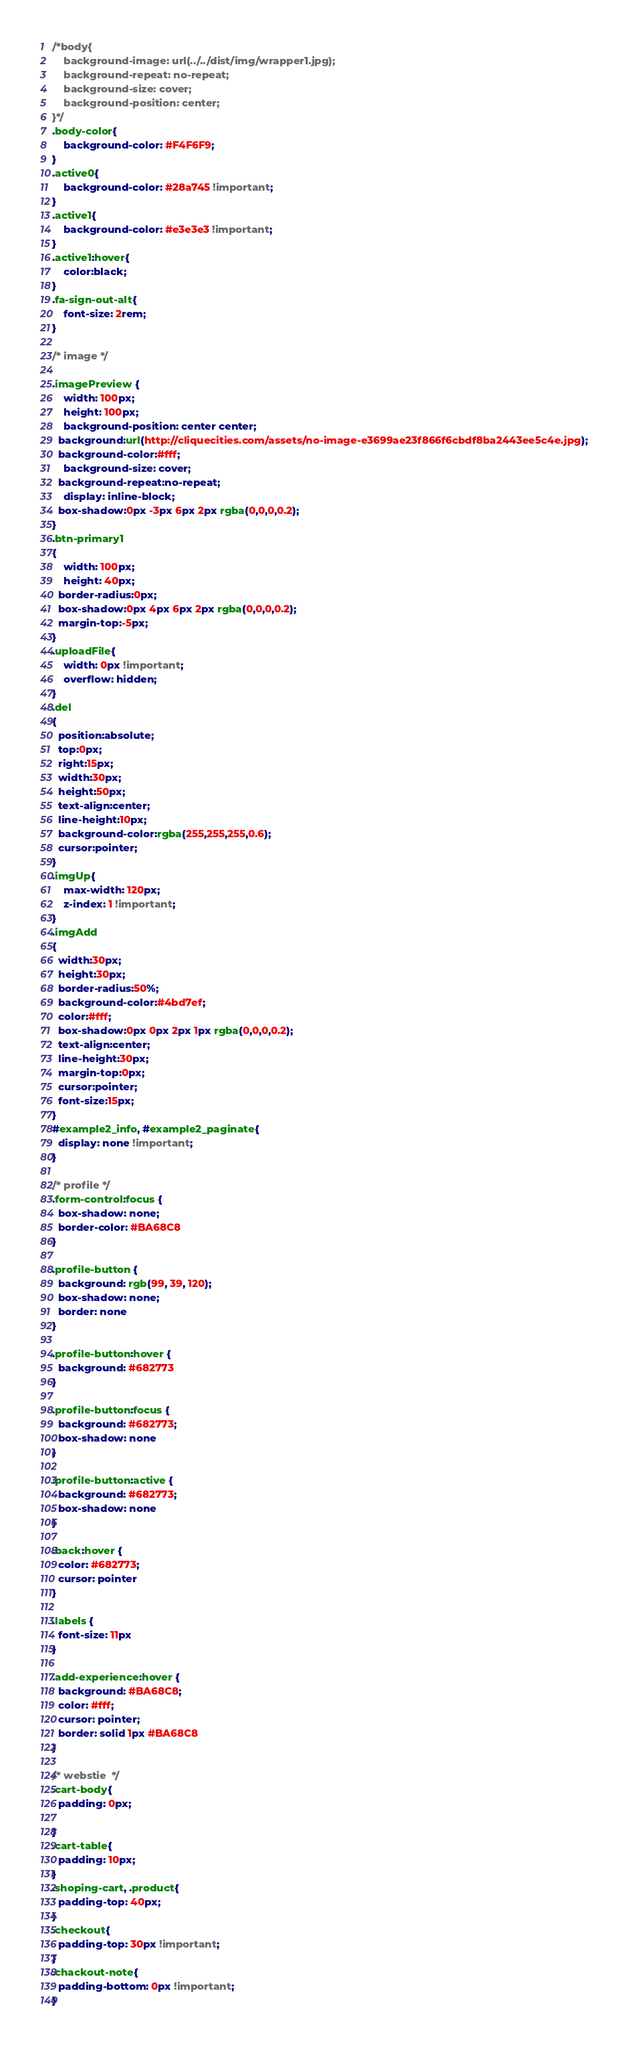<code> <loc_0><loc_0><loc_500><loc_500><_CSS_>/*body{
    background-image: url(../../dist/img/wrapper1.jpg);
    background-repeat: no-repeat;
    background-size: cover;
    background-position: center;
}*/
.body-color{
    background-color: #F4F6F9;
}
.active0{
    background-color: #28a745 !important;
}
.active1{
    background-color: #e3e3e3 !important;
}
.active1:hover{
    color:black;
}
.fa-sign-out-alt{
    font-size: 2rem;
}

/* image */

.imagePreview {
    width: 100px;
    height: 100px;
    background-position: center center;
  background:url(http://cliquecities.com/assets/no-image-e3699ae23f866f6cbdf8ba2443ee5c4e.jpg);
  background-color:#fff;
    background-size: cover;
  background-repeat:no-repeat;
    display: inline-block;
  box-shadow:0px -3px 6px 2px rgba(0,0,0,0.2);
}
.btn-primary1
{
    width: 100px;
    height: 40px;
  border-radius:0px;
  box-shadow:0px 4px 6px 2px rgba(0,0,0,0.2);
  margin-top:-5px;
}
.uploadFile{
    width: 0px !important;
    overflow: hidden;
}
.del
{
  position:absolute;
  top:0px;
  right:15px;
  width:30px;
  height:50px;
  text-align:center;
  line-height:10px;
  background-color:rgba(255,255,255,0.6);
  cursor:pointer;
}
.imgUp{
    max-width: 120px;
    z-index: 1 !important;
}
.imgAdd
{
  width:30px;
  height:30px;
  border-radius:50%;
  background-color:#4bd7ef;
  color:#fff;
  box-shadow:0px 0px 2px 1px rgba(0,0,0,0.2);
  text-align:center;
  line-height:30px;
  margin-top:0px;
  cursor:pointer;
  font-size:15px;
}
#example2_info, #example2_paginate{
  display: none !important;
}

/* profile */
.form-control:focus {
  box-shadow: none;
  border-color: #BA68C8
}

.profile-button {
  background: rgb(99, 39, 120);
  box-shadow: none;
  border: none
}

.profile-button:hover {
  background: #682773
}

.profile-button:focus {
  background: #682773;
  box-shadow: none
}

.profile-button:active {
  background: #682773;
  box-shadow: none
}

.back:hover {
  color: #682773;
  cursor: pointer
}

.labels {
  font-size: 11px
}

.add-experience:hover {
  background: #BA68C8;
  color: #fff;
  cursor: pointer;
  border: solid 1px #BA68C8
}

/* webstie  */
.cart-body{
  padding: 0px;

}
.cart-table{
  padding: 10px;
}
.shoping-cart, .product{
  padding-top: 40px;
}
.checkout{
  padding-top: 30px !important;
}
.chackout-note{
  padding-bottom: 0px !important;
}
</code> 